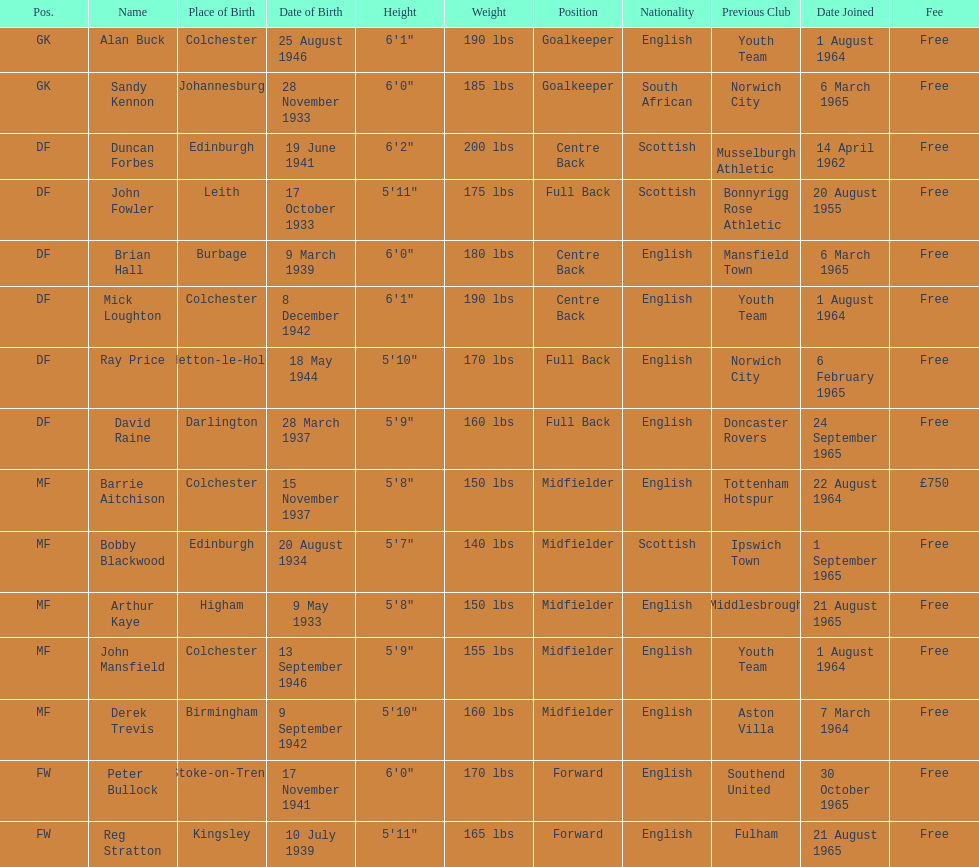Can you parse all the data within this table? {'header': ['Pos.', 'Name', 'Place of Birth', 'Date of Birth', 'Height', 'Weight', 'Position', 'Nationality', 'Previous Club', 'Date Joined', 'Fee'], 'rows': [['GK', 'Alan Buck', 'Colchester', '25 August 1946', '6\'1"', '190 lbs', 'Goalkeeper', 'English', 'Youth Team', '1 August 1964', 'Free'], ['GK', 'Sandy Kennon', 'Johannesburg', '28 November 1933', '6\'0"', '185 lbs', 'Goalkeeper', 'South African', 'Norwich City', '6 March 1965', 'Free'], ['DF', 'Duncan Forbes', 'Edinburgh', '19 June 1941', '6\'2"', '200 lbs', 'Centre Back', 'Scottish', 'Musselburgh Athletic', '14 April 1962', 'Free'], ['DF', 'John Fowler', 'Leith', '17 October 1933', '5\'11"', '175 lbs', 'Full Back', 'Scottish', 'Bonnyrigg Rose Athletic', '20 August 1955', 'Free'], ['DF', 'Brian Hall', 'Burbage', '9 March 1939', '6\'0"', '180 lbs', 'Centre Back', 'English', 'Mansfield Town', '6 March 1965', 'Free'], ['DF', 'Mick Loughton', 'Colchester', '8 December 1942', '6\'1"', '190 lbs', 'Centre Back', 'English', 'Youth Team', '1 August 1964', 'Free'], ['DF', 'Ray Price', 'Hetton-le-Hole', '18 May 1944', '5\'10"', '170 lbs', 'Full Back', 'English', 'Norwich City', '6 February 1965', 'Free'], ['DF', 'David Raine', 'Darlington', '28 March 1937', '5\'9"', '160 lbs', 'Full Back', 'English', 'Doncaster Rovers', '24 September 1965', 'Free'], ['MF', 'Barrie Aitchison', 'Colchester', '15 November 1937', '5\'8"', '150 lbs', 'Midfielder', 'English', 'Tottenham Hotspur', '22 August 1964', '£750'], ['MF', 'Bobby Blackwood', 'Edinburgh', '20 August 1934', '5\'7"', '140 lbs', 'Midfielder', 'Scottish', 'Ipswich Town', '1 September 1965', 'Free'], ['MF', 'Arthur Kaye', 'Higham', '9 May 1933', '5\'8"', '150 lbs', 'Midfielder', 'English', 'Middlesbrough', '21 August 1965', 'Free'], ['MF', 'John Mansfield', 'Colchester', '13 September 1946', '5\'9"', '155 lbs', 'Midfielder', 'English', 'Youth Team', '1 August 1964', 'Free'], ['MF', 'Derek Trevis', 'Birmingham', '9 September 1942', '5\'10"', '160 lbs', 'Midfielder', 'English', 'Aston Villa', '7 March 1964', 'Free'], ['FW', 'Peter Bullock', 'Stoke-on-Trent', '17 November 1941', '6\'0"', '170 lbs', 'Forward', 'English', 'Southend United', '30 October 1965', 'Free'], ['FW', 'Reg Stratton', 'Kingsley', '10 July 1939', '5\'11"', '165 lbs', 'Forward', 'English', 'Fulham', '21 August 1965', 'Free']]} What is the date of the lst player that joined? 20 August 1955. 